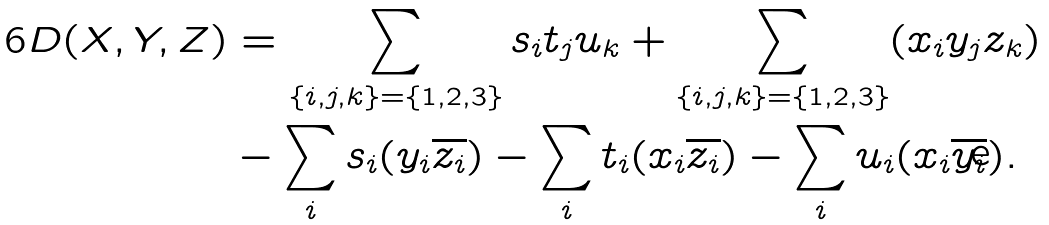<formula> <loc_0><loc_0><loc_500><loc_500>6 D ( X , Y , Z ) & = \sum _ { \{ i , j , k \} = \{ 1 , 2 , 3 \} } s _ { i } t _ { j } u _ { k } + \sum _ { \{ i , j , k \} = \{ 1 , 2 , 3 \} } ( x _ { i } y _ { j } z _ { k } ) \\ & - \sum _ { i } s _ { i } ( y _ { i } \overline { z _ { i } } ) - \sum _ { i } t _ { i } ( x _ { i } \overline { z _ { i } } ) - \sum _ { i } u _ { i } ( x _ { i } \overline { y _ { i } } ) .</formula> 